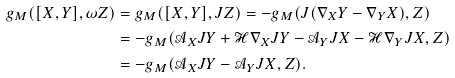Convert formula to latex. <formula><loc_0><loc_0><loc_500><loc_500>g _ { M } ( [ X , Y ] , \omega Z ) & = g _ { M } ( [ X , Y ] , J Z ) = - g _ { M } ( J ( \nabla _ { X } Y - \nabla _ { Y } X ) , Z ) \\ & = - g _ { M } ( \mathcal { A } _ { X } J Y + \mathcal { H } \nabla _ { X } J Y - \mathcal { A } _ { Y } J X - \mathcal { H } \nabla _ { Y } J X , Z ) \\ & = - g _ { M } ( \mathcal { A } _ { X } J Y - \mathcal { A } _ { Y } J X , Z ) .</formula> 